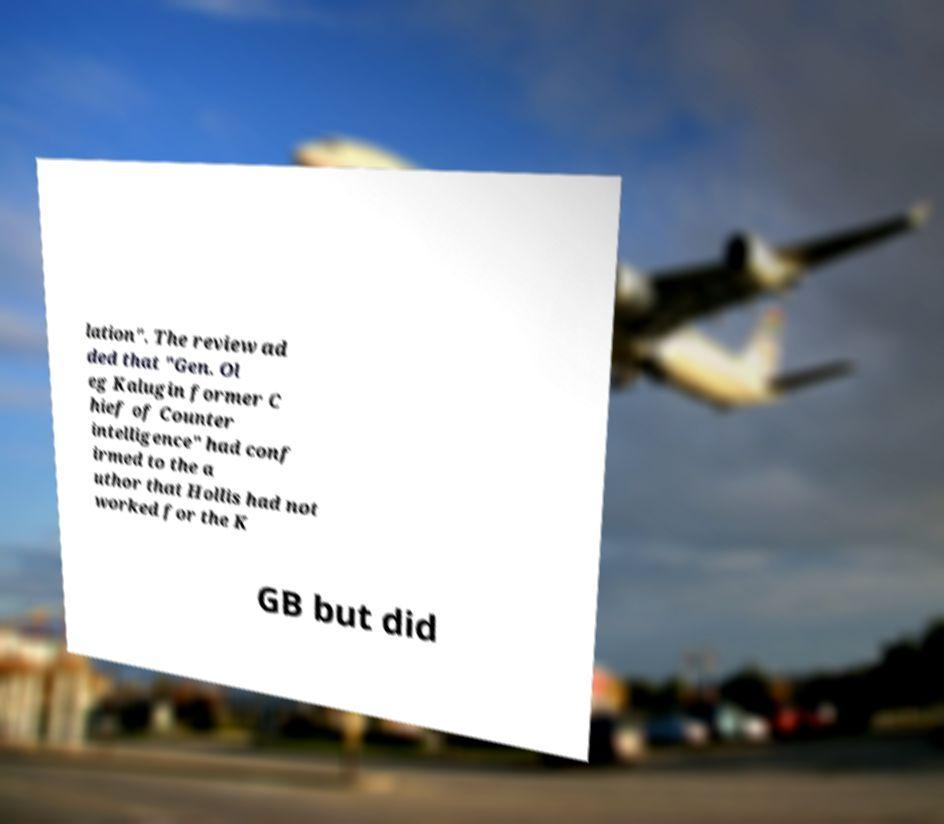There's text embedded in this image that I need extracted. Can you transcribe it verbatim? lation". The review ad ded that "Gen. Ol eg Kalugin former C hief of Counter intelligence" had conf irmed to the a uthor that Hollis had not worked for the K GB but did 